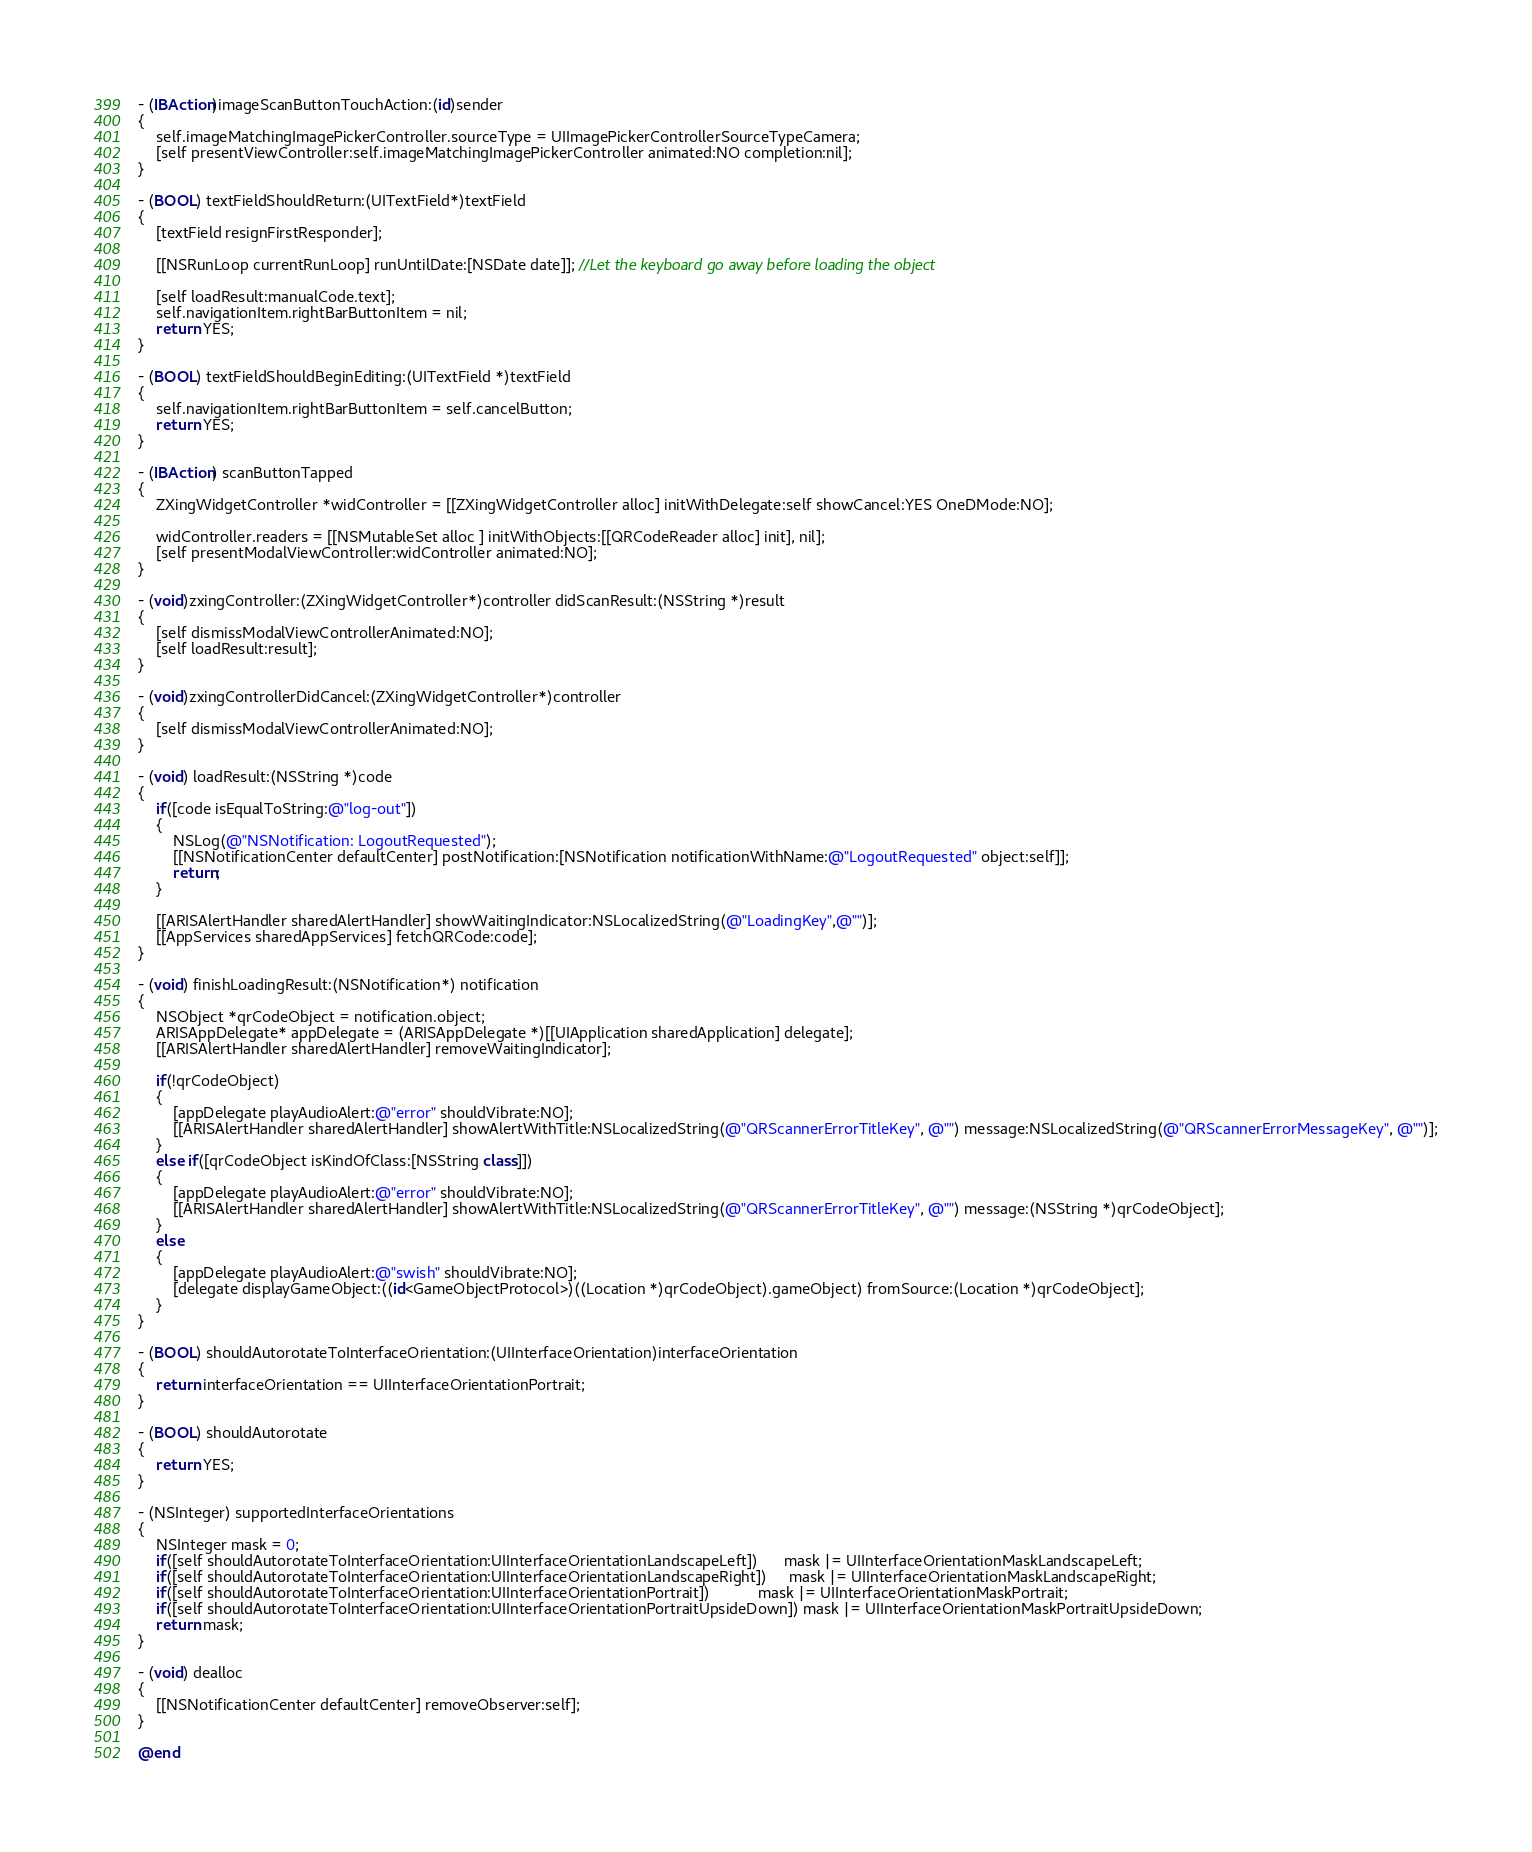Convert code to text. <code><loc_0><loc_0><loc_500><loc_500><_ObjectiveC_>- (IBAction)imageScanButtonTouchAction:(id)sender
{	
	self.imageMatchingImagePickerController.sourceType = UIImagePickerControllerSourceTypeCamera;
	[self presentViewController:self.imageMatchingImagePickerController animated:NO completion:nil];
}

- (BOOL) textFieldShouldReturn:(UITextField*)textField
{	
	[textField resignFirstResponder]; 
	
	[[NSRunLoop currentRunLoop] runUntilDate:[NSDate date]]; //Let the keyboard go away before loading the object
	
	[self loadResult:manualCode.text];
    self.navigationItem.rightBarButtonItem = nil;	
	return YES;
}

- (BOOL) textFieldShouldBeginEditing:(UITextField *)textField
{    
    self.navigationItem.rightBarButtonItem = self.cancelButton;	
    return YES;
}

- (IBAction) scanButtonTapped
{
    ZXingWidgetController *widController = [[ZXingWidgetController alloc] initWithDelegate:self showCancel:YES OneDMode:NO];
    
    widController.readers = [[NSMutableSet alloc ] initWithObjects:[[QRCodeReader alloc] init], nil];
    [self presentModalViewController:widController animated:NO];
}

- (void)zxingController:(ZXingWidgetController*)controller didScanResult:(NSString *)result
{
    [self dismissModalViewControllerAnimated:NO];
    [self loadResult:result];
}

- (void)zxingControllerDidCancel:(ZXingWidgetController*)controller
{
    [self dismissModalViewControllerAnimated:NO];
}

- (void) loadResult:(NSString *)code
{
    if([code isEqualToString:@"log-out"])
    {
        NSLog(@"NSNotification: LogoutRequested");
        [[NSNotificationCenter defaultCenter] postNotification:[NSNotification notificationWithName:@"LogoutRequested" object:self]];
        return;
    }
    
    [[ARISAlertHandler sharedAlertHandler] showWaitingIndicator:NSLocalizedString(@"LoadingKey",@"")];
	[[AppServices sharedAppServices] fetchQRCode:code];
}

- (void) finishLoadingResult:(NSNotification*) notification
{	
	NSObject *qrCodeObject = notification.object;
	ARISAppDelegate* appDelegate = (ARISAppDelegate *)[[UIApplication sharedApplication] delegate];
    [[ARISAlertHandler sharedAlertHandler] removeWaitingIndicator];
    
	if(!qrCodeObject)
    {
		[appDelegate playAudioAlert:@"error" shouldVibrate:NO];
        [[ARISAlertHandler sharedAlertHandler] showAlertWithTitle:NSLocalizedString(@"QRScannerErrorTitleKey", @"") message:NSLocalizedString(@"QRScannerErrorMessageKey", @"")];
	}
	else if([qrCodeObject isKindOfClass:[NSString class]])
    {
        [appDelegate playAudioAlert:@"error" shouldVibrate:NO];
        [[ARISAlertHandler sharedAlertHandler] showAlertWithTitle:NSLocalizedString(@"QRScannerErrorTitleKey", @"") message:(NSString *)qrCodeObject];
    }
    else
    {
		[appDelegate playAudioAlert:@"swish" shouldVibrate:NO];
		[delegate displayGameObject:((id<GameObjectProtocol>)((Location *)qrCodeObject).gameObject) fromSource:(Location *)qrCodeObject];
	}
}

- (BOOL) shouldAutorotateToInterfaceOrientation:(UIInterfaceOrientation)interfaceOrientation
{
	return interfaceOrientation == UIInterfaceOrientationPortrait;
}

- (BOOL) shouldAutorotate
{
    return YES;
}

- (NSInteger) supportedInterfaceOrientations
{
    NSInteger mask = 0;
    if([self shouldAutorotateToInterfaceOrientation:UIInterfaceOrientationLandscapeLeft])      mask |= UIInterfaceOrientationMaskLandscapeLeft;
    if([self shouldAutorotateToInterfaceOrientation:UIInterfaceOrientationLandscapeRight])     mask |= UIInterfaceOrientationMaskLandscapeRight;
    if([self shouldAutorotateToInterfaceOrientation:UIInterfaceOrientationPortrait])           mask |= UIInterfaceOrientationMaskPortrait;
    if([self shouldAutorotateToInterfaceOrientation:UIInterfaceOrientationPortraitUpsideDown]) mask |= UIInterfaceOrientationMaskPortraitUpsideDown;
    return mask;
}

- (void) dealloc
{
    [[NSNotificationCenter defaultCenter] removeObserver:self];
}

@end
</code> 